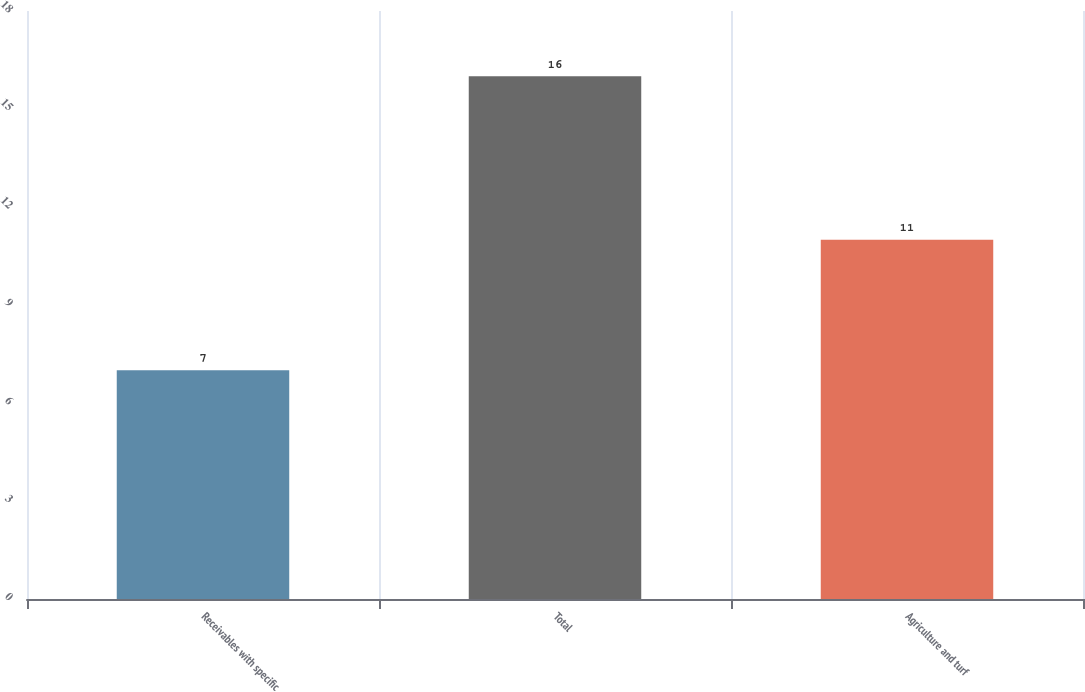<chart> <loc_0><loc_0><loc_500><loc_500><bar_chart><fcel>Receivables with specific<fcel>Total<fcel>Agriculture and turf<nl><fcel>7<fcel>16<fcel>11<nl></chart> 